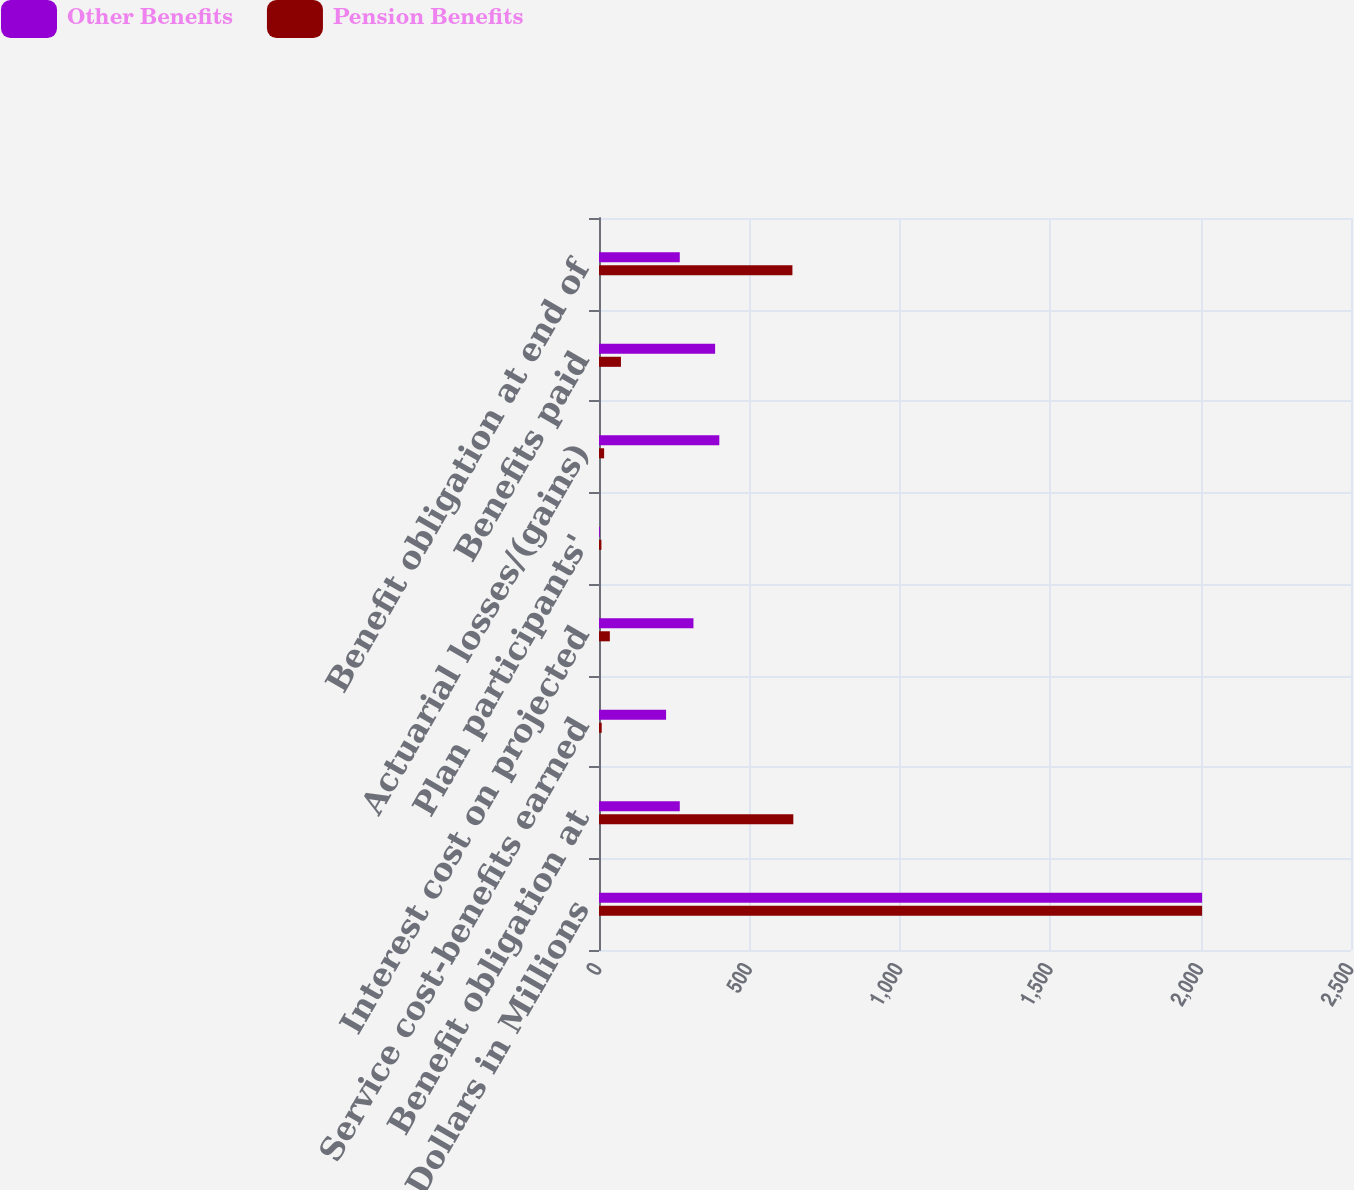<chart> <loc_0><loc_0><loc_500><loc_500><stacked_bar_chart><ecel><fcel>Dollars in Millions<fcel>Benefit obligation at<fcel>Service cost-benefits earned<fcel>Interest cost on projected<fcel>Plan participants'<fcel>Actuarial losses/(gains)<fcel>Benefits paid<fcel>Benefit obligation at end of<nl><fcel>Other Benefits<fcel>2005<fcel>268.5<fcel>223<fcel>314<fcel>3<fcel>400<fcel>386<fcel>268.5<nl><fcel>Pension Benefits<fcel>2005<fcel>646<fcel>9<fcel>36<fcel>8<fcel>17<fcel>73<fcel>643<nl></chart> 